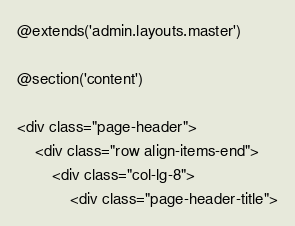<code> <loc_0><loc_0><loc_500><loc_500><_PHP_>@extends('admin.layouts.master')

@section('content')

<div class="page-header">
    <div class="row align-items-end">
        <div class="col-lg-8">
            <div class="page-header-title"></code> 